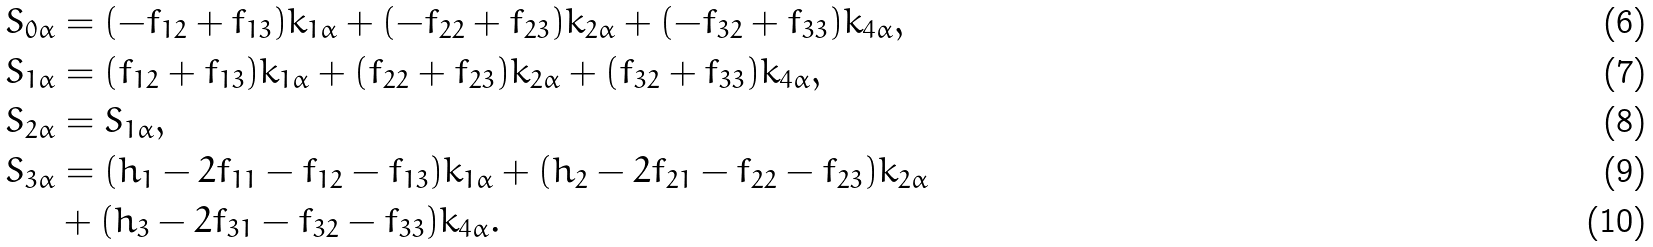Convert formula to latex. <formula><loc_0><loc_0><loc_500><loc_500>S _ { 0 \alpha } & = ( - f _ { 1 2 } + f _ { 1 3 } ) k _ { 1 \alpha } + ( - f _ { 2 2 } + f _ { 2 3 } ) k _ { 2 \alpha } + ( - f _ { 3 2 } + f _ { 3 3 } ) k _ { 4 \alpha } , \\ S _ { 1 \alpha } & = ( f _ { 1 2 } + f _ { 1 3 } ) k _ { 1 \alpha } + ( f _ { 2 2 } + f _ { 2 3 } ) k _ { 2 \alpha } + ( f _ { 3 2 } + f _ { 3 3 } ) k _ { 4 \alpha } , \\ S _ { 2 \alpha } & = S _ { 1 \alpha } , \\ S _ { 3 \alpha } & = ( h _ { 1 } - 2 f _ { 1 1 } - f _ { 1 2 } - f _ { 1 3 } ) k _ { 1 \alpha } + ( h _ { 2 } - 2 f _ { 2 1 } - f _ { 2 2 } - f _ { 2 3 } ) k _ { 2 \alpha } \\ & + ( h _ { 3 } - 2 f _ { 3 1 } - f _ { 3 2 } - f _ { 3 3 } ) k _ { 4 \alpha } .</formula> 